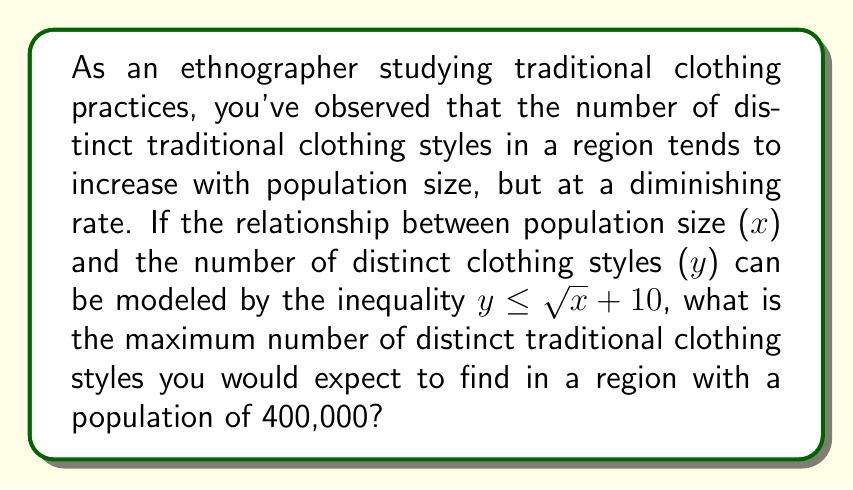What is the answer to this math problem? To solve this problem, we need to follow these steps:

1. Identify the given inequality: $y \leq \sqrt{x} + 10$

2. Substitute the given population size into the inequality:
   $x = 400,000$

3. Calculate the right-hand side of the inequality:
   $y \leq \sqrt{400,000} + 10$

4. Simplify:
   $\sqrt{400,000} = \sqrt{4 \times 100,000} = \sqrt{4} \times \sqrt{100,000} = 2 \times 200 = 400$

5. Complete the calculation:
   $y \leq 400 + 10 = 410$

6. Interpret the result:
   The inequality gives us the upper bound for the number of distinct traditional clothing styles. Since we're looking for the maximum number, we take the value that makes the inequality an equality.

Therefore, the maximum number of distinct traditional clothing styles expected in a region with a population of 400,000 is 410.
Answer: 410 